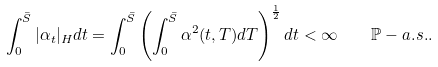Convert formula to latex. <formula><loc_0><loc_0><loc_500><loc_500>\int _ { 0 } ^ { \bar { S } } | \alpha _ { t } | _ { H } d t = \int _ { 0 } ^ { \bar { S } } \left ( \int _ { 0 } ^ { \bar { S } } \alpha ^ { 2 } ( t , T ) d T \right ) ^ { \frac { 1 } { 2 } } d t < \infty \quad \mathbb { P } - a . s . .</formula> 